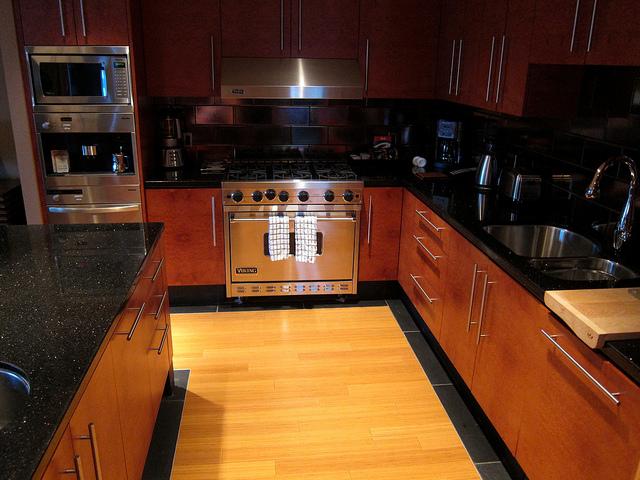How many towels are there?
Concise answer only. 2. Are the countertops made of granite?
Answer briefly. Yes. Where is the microwave located?
Short answer required. Above oven. 